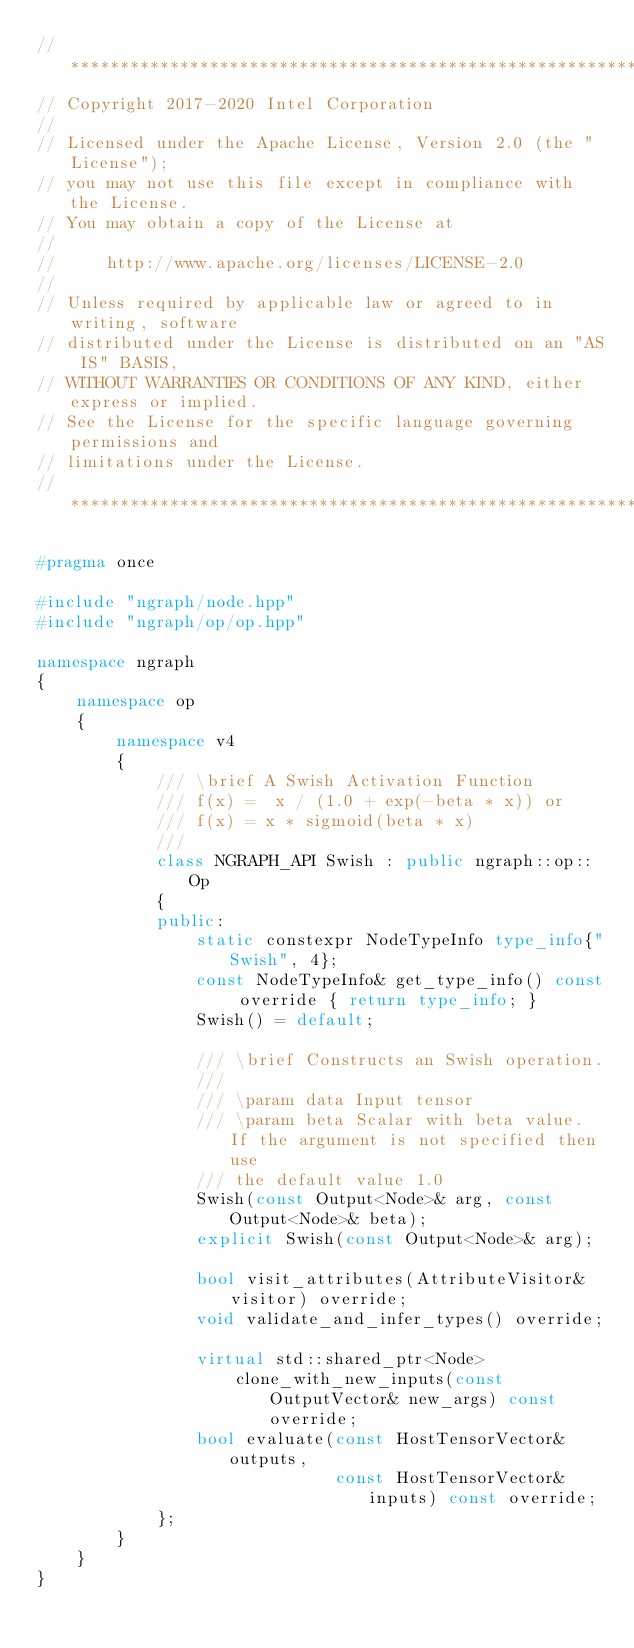<code> <loc_0><loc_0><loc_500><loc_500><_C++_>//*****************************************************************************
// Copyright 2017-2020 Intel Corporation
//
// Licensed under the Apache License, Version 2.0 (the "License");
// you may not use this file except in compliance with the License.
// You may obtain a copy of the License at
//
//     http://www.apache.org/licenses/LICENSE-2.0
//
// Unless required by applicable law or agreed to in writing, software
// distributed under the License is distributed on an "AS IS" BASIS,
// WITHOUT WARRANTIES OR CONDITIONS OF ANY KIND, either express or implied.
// See the License for the specific language governing permissions and
// limitations under the License.
//*****************************************************************************

#pragma once

#include "ngraph/node.hpp"
#include "ngraph/op/op.hpp"

namespace ngraph
{
    namespace op
    {
        namespace v4
        {
            /// \brief A Swish Activation Function
            /// f(x) =  x / (1.0 + exp(-beta * x)) or
            /// f(x) = x * sigmoid(beta * x)
            ///
            class NGRAPH_API Swish : public ngraph::op::Op
            {
            public:
                static constexpr NodeTypeInfo type_info{"Swish", 4};
                const NodeTypeInfo& get_type_info() const override { return type_info; }
                Swish() = default;

                /// \brief Constructs an Swish operation.
                ///
                /// \param data Input tensor
                /// \param beta Scalar with beta value. If the argument is not specified then use
                /// the default value 1.0
                Swish(const Output<Node>& arg, const Output<Node>& beta);
                explicit Swish(const Output<Node>& arg);

                bool visit_attributes(AttributeVisitor& visitor) override;
                void validate_and_infer_types() override;

                virtual std::shared_ptr<Node>
                    clone_with_new_inputs(const OutputVector& new_args) const override;
                bool evaluate(const HostTensorVector& outputs,
                              const HostTensorVector& inputs) const override;
            };
        }
    }
}
</code> 